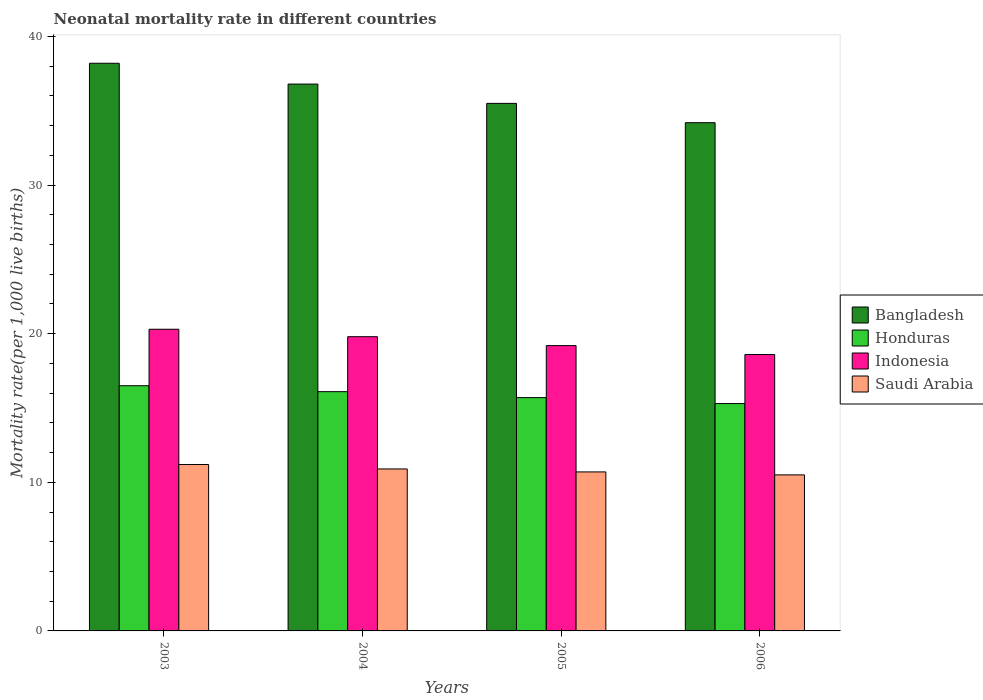Are the number of bars per tick equal to the number of legend labels?
Your response must be concise. Yes. How many bars are there on the 4th tick from the right?
Give a very brief answer. 4. What is the neonatal mortality rate in Indonesia in 2005?
Offer a terse response. 19.2. Across all years, what is the maximum neonatal mortality rate in Indonesia?
Make the answer very short. 20.3. Across all years, what is the minimum neonatal mortality rate in Bangladesh?
Your answer should be very brief. 34.2. In which year was the neonatal mortality rate in Indonesia minimum?
Provide a short and direct response. 2006. What is the total neonatal mortality rate in Bangladesh in the graph?
Offer a terse response. 144.7. What is the difference between the neonatal mortality rate in Saudi Arabia in 2003 and that in 2004?
Provide a short and direct response. 0.3. What is the difference between the neonatal mortality rate in Indonesia in 2003 and the neonatal mortality rate in Saudi Arabia in 2004?
Ensure brevity in your answer.  9.4. What is the average neonatal mortality rate in Indonesia per year?
Your response must be concise. 19.48. In the year 2005, what is the difference between the neonatal mortality rate in Saudi Arabia and neonatal mortality rate in Honduras?
Provide a short and direct response. -5. In how many years, is the neonatal mortality rate in Saudi Arabia greater than 8?
Provide a short and direct response. 4. What is the ratio of the neonatal mortality rate in Honduras in 2005 to that in 2006?
Offer a very short reply. 1.03. What is the difference between the highest and the second highest neonatal mortality rate in Honduras?
Your response must be concise. 0.4. Is it the case that in every year, the sum of the neonatal mortality rate in Saudi Arabia and neonatal mortality rate in Honduras is greater than the sum of neonatal mortality rate in Indonesia and neonatal mortality rate in Bangladesh?
Provide a short and direct response. No. Is it the case that in every year, the sum of the neonatal mortality rate in Indonesia and neonatal mortality rate in Honduras is greater than the neonatal mortality rate in Bangladesh?
Provide a succinct answer. No. Are the values on the major ticks of Y-axis written in scientific E-notation?
Provide a succinct answer. No. Does the graph contain any zero values?
Your answer should be very brief. No. What is the title of the graph?
Offer a very short reply. Neonatal mortality rate in different countries. Does "Kazakhstan" appear as one of the legend labels in the graph?
Make the answer very short. No. What is the label or title of the Y-axis?
Make the answer very short. Mortality rate(per 1,0 live births). What is the Mortality rate(per 1,000 live births) of Bangladesh in 2003?
Provide a succinct answer. 38.2. What is the Mortality rate(per 1,000 live births) of Honduras in 2003?
Offer a very short reply. 16.5. What is the Mortality rate(per 1,000 live births) in Indonesia in 2003?
Your response must be concise. 20.3. What is the Mortality rate(per 1,000 live births) of Bangladesh in 2004?
Ensure brevity in your answer.  36.8. What is the Mortality rate(per 1,000 live births) in Indonesia in 2004?
Your response must be concise. 19.8. What is the Mortality rate(per 1,000 live births) in Saudi Arabia in 2004?
Provide a short and direct response. 10.9. What is the Mortality rate(per 1,000 live births) of Bangladesh in 2005?
Ensure brevity in your answer.  35.5. What is the Mortality rate(per 1,000 live births) in Saudi Arabia in 2005?
Ensure brevity in your answer.  10.7. What is the Mortality rate(per 1,000 live births) in Bangladesh in 2006?
Your response must be concise. 34.2. What is the Mortality rate(per 1,000 live births) of Honduras in 2006?
Keep it short and to the point. 15.3. Across all years, what is the maximum Mortality rate(per 1,000 live births) in Bangladesh?
Give a very brief answer. 38.2. Across all years, what is the maximum Mortality rate(per 1,000 live births) in Honduras?
Offer a very short reply. 16.5. Across all years, what is the maximum Mortality rate(per 1,000 live births) in Indonesia?
Offer a terse response. 20.3. Across all years, what is the minimum Mortality rate(per 1,000 live births) of Bangladesh?
Your response must be concise. 34.2. Across all years, what is the minimum Mortality rate(per 1,000 live births) in Indonesia?
Your answer should be very brief. 18.6. Across all years, what is the minimum Mortality rate(per 1,000 live births) in Saudi Arabia?
Your response must be concise. 10.5. What is the total Mortality rate(per 1,000 live births) in Bangladesh in the graph?
Offer a terse response. 144.7. What is the total Mortality rate(per 1,000 live births) of Honduras in the graph?
Ensure brevity in your answer.  63.6. What is the total Mortality rate(per 1,000 live births) in Indonesia in the graph?
Make the answer very short. 77.9. What is the total Mortality rate(per 1,000 live births) of Saudi Arabia in the graph?
Provide a succinct answer. 43.3. What is the difference between the Mortality rate(per 1,000 live births) of Bangladesh in 2003 and that in 2004?
Your answer should be compact. 1.4. What is the difference between the Mortality rate(per 1,000 live births) of Saudi Arabia in 2003 and that in 2004?
Offer a terse response. 0.3. What is the difference between the Mortality rate(per 1,000 live births) in Indonesia in 2003 and that in 2005?
Offer a very short reply. 1.1. What is the difference between the Mortality rate(per 1,000 live births) in Saudi Arabia in 2003 and that in 2005?
Offer a very short reply. 0.5. What is the difference between the Mortality rate(per 1,000 live births) of Indonesia in 2003 and that in 2006?
Provide a succinct answer. 1.7. What is the difference between the Mortality rate(per 1,000 live births) in Saudi Arabia in 2004 and that in 2005?
Your answer should be compact. 0.2. What is the difference between the Mortality rate(per 1,000 live births) in Bangladesh in 2004 and that in 2006?
Provide a succinct answer. 2.6. What is the difference between the Mortality rate(per 1,000 live births) of Indonesia in 2004 and that in 2006?
Make the answer very short. 1.2. What is the difference between the Mortality rate(per 1,000 live births) of Bangladesh in 2005 and that in 2006?
Provide a succinct answer. 1.3. What is the difference between the Mortality rate(per 1,000 live births) in Honduras in 2005 and that in 2006?
Provide a short and direct response. 0.4. What is the difference between the Mortality rate(per 1,000 live births) in Bangladesh in 2003 and the Mortality rate(per 1,000 live births) in Honduras in 2004?
Your answer should be very brief. 22.1. What is the difference between the Mortality rate(per 1,000 live births) in Bangladesh in 2003 and the Mortality rate(per 1,000 live births) in Indonesia in 2004?
Your answer should be very brief. 18.4. What is the difference between the Mortality rate(per 1,000 live births) of Bangladesh in 2003 and the Mortality rate(per 1,000 live births) of Saudi Arabia in 2004?
Provide a short and direct response. 27.3. What is the difference between the Mortality rate(per 1,000 live births) of Bangladesh in 2003 and the Mortality rate(per 1,000 live births) of Honduras in 2005?
Offer a terse response. 22.5. What is the difference between the Mortality rate(per 1,000 live births) in Indonesia in 2003 and the Mortality rate(per 1,000 live births) in Saudi Arabia in 2005?
Provide a succinct answer. 9.6. What is the difference between the Mortality rate(per 1,000 live births) in Bangladesh in 2003 and the Mortality rate(per 1,000 live births) in Honduras in 2006?
Give a very brief answer. 22.9. What is the difference between the Mortality rate(per 1,000 live births) of Bangladesh in 2003 and the Mortality rate(per 1,000 live births) of Indonesia in 2006?
Your answer should be compact. 19.6. What is the difference between the Mortality rate(per 1,000 live births) of Bangladesh in 2003 and the Mortality rate(per 1,000 live births) of Saudi Arabia in 2006?
Offer a terse response. 27.7. What is the difference between the Mortality rate(per 1,000 live births) of Honduras in 2003 and the Mortality rate(per 1,000 live births) of Indonesia in 2006?
Your answer should be very brief. -2.1. What is the difference between the Mortality rate(per 1,000 live births) of Honduras in 2003 and the Mortality rate(per 1,000 live births) of Saudi Arabia in 2006?
Provide a succinct answer. 6. What is the difference between the Mortality rate(per 1,000 live births) in Indonesia in 2003 and the Mortality rate(per 1,000 live births) in Saudi Arabia in 2006?
Provide a short and direct response. 9.8. What is the difference between the Mortality rate(per 1,000 live births) in Bangladesh in 2004 and the Mortality rate(per 1,000 live births) in Honduras in 2005?
Offer a terse response. 21.1. What is the difference between the Mortality rate(per 1,000 live births) in Bangladesh in 2004 and the Mortality rate(per 1,000 live births) in Indonesia in 2005?
Ensure brevity in your answer.  17.6. What is the difference between the Mortality rate(per 1,000 live births) of Bangladesh in 2004 and the Mortality rate(per 1,000 live births) of Saudi Arabia in 2005?
Your answer should be compact. 26.1. What is the difference between the Mortality rate(per 1,000 live births) of Honduras in 2004 and the Mortality rate(per 1,000 live births) of Saudi Arabia in 2005?
Give a very brief answer. 5.4. What is the difference between the Mortality rate(per 1,000 live births) in Bangladesh in 2004 and the Mortality rate(per 1,000 live births) in Honduras in 2006?
Offer a very short reply. 21.5. What is the difference between the Mortality rate(per 1,000 live births) in Bangladesh in 2004 and the Mortality rate(per 1,000 live births) in Indonesia in 2006?
Provide a succinct answer. 18.2. What is the difference between the Mortality rate(per 1,000 live births) of Bangladesh in 2004 and the Mortality rate(per 1,000 live births) of Saudi Arabia in 2006?
Your answer should be compact. 26.3. What is the difference between the Mortality rate(per 1,000 live births) in Indonesia in 2004 and the Mortality rate(per 1,000 live births) in Saudi Arabia in 2006?
Your answer should be compact. 9.3. What is the difference between the Mortality rate(per 1,000 live births) of Bangladesh in 2005 and the Mortality rate(per 1,000 live births) of Honduras in 2006?
Your answer should be very brief. 20.2. What is the difference between the Mortality rate(per 1,000 live births) in Honduras in 2005 and the Mortality rate(per 1,000 live births) in Saudi Arabia in 2006?
Offer a very short reply. 5.2. What is the difference between the Mortality rate(per 1,000 live births) in Indonesia in 2005 and the Mortality rate(per 1,000 live births) in Saudi Arabia in 2006?
Make the answer very short. 8.7. What is the average Mortality rate(per 1,000 live births) in Bangladesh per year?
Keep it short and to the point. 36.17. What is the average Mortality rate(per 1,000 live births) in Honduras per year?
Make the answer very short. 15.9. What is the average Mortality rate(per 1,000 live births) in Indonesia per year?
Keep it short and to the point. 19.48. What is the average Mortality rate(per 1,000 live births) of Saudi Arabia per year?
Make the answer very short. 10.82. In the year 2003, what is the difference between the Mortality rate(per 1,000 live births) in Bangladesh and Mortality rate(per 1,000 live births) in Honduras?
Offer a terse response. 21.7. In the year 2003, what is the difference between the Mortality rate(per 1,000 live births) of Bangladesh and Mortality rate(per 1,000 live births) of Indonesia?
Ensure brevity in your answer.  17.9. In the year 2003, what is the difference between the Mortality rate(per 1,000 live births) in Honduras and Mortality rate(per 1,000 live births) in Saudi Arabia?
Ensure brevity in your answer.  5.3. In the year 2003, what is the difference between the Mortality rate(per 1,000 live births) in Indonesia and Mortality rate(per 1,000 live births) in Saudi Arabia?
Provide a succinct answer. 9.1. In the year 2004, what is the difference between the Mortality rate(per 1,000 live births) of Bangladesh and Mortality rate(per 1,000 live births) of Honduras?
Provide a short and direct response. 20.7. In the year 2004, what is the difference between the Mortality rate(per 1,000 live births) of Bangladesh and Mortality rate(per 1,000 live births) of Saudi Arabia?
Your response must be concise. 25.9. In the year 2004, what is the difference between the Mortality rate(per 1,000 live births) of Honduras and Mortality rate(per 1,000 live births) of Saudi Arabia?
Give a very brief answer. 5.2. In the year 2005, what is the difference between the Mortality rate(per 1,000 live births) of Bangladesh and Mortality rate(per 1,000 live births) of Honduras?
Your answer should be compact. 19.8. In the year 2005, what is the difference between the Mortality rate(per 1,000 live births) of Bangladesh and Mortality rate(per 1,000 live births) of Saudi Arabia?
Ensure brevity in your answer.  24.8. In the year 2005, what is the difference between the Mortality rate(per 1,000 live births) of Honduras and Mortality rate(per 1,000 live births) of Indonesia?
Provide a short and direct response. -3.5. In the year 2005, what is the difference between the Mortality rate(per 1,000 live births) in Honduras and Mortality rate(per 1,000 live births) in Saudi Arabia?
Keep it short and to the point. 5. In the year 2006, what is the difference between the Mortality rate(per 1,000 live births) of Bangladesh and Mortality rate(per 1,000 live births) of Saudi Arabia?
Ensure brevity in your answer.  23.7. In the year 2006, what is the difference between the Mortality rate(per 1,000 live births) in Honduras and Mortality rate(per 1,000 live births) in Saudi Arabia?
Provide a succinct answer. 4.8. In the year 2006, what is the difference between the Mortality rate(per 1,000 live births) in Indonesia and Mortality rate(per 1,000 live births) in Saudi Arabia?
Keep it short and to the point. 8.1. What is the ratio of the Mortality rate(per 1,000 live births) in Bangladesh in 2003 to that in 2004?
Make the answer very short. 1.04. What is the ratio of the Mortality rate(per 1,000 live births) in Honduras in 2003 to that in 2004?
Keep it short and to the point. 1.02. What is the ratio of the Mortality rate(per 1,000 live births) of Indonesia in 2003 to that in 2004?
Provide a short and direct response. 1.03. What is the ratio of the Mortality rate(per 1,000 live births) of Saudi Arabia in 2003 to that in 2004?
Your answer should be very brief. 1.03. What is the ratio of the Mortality rate(per 1,000 live births) of Bangladesh in 2003 to that in 2005?
Provide a short and direct response. 1.08. What is the ratio of the Mortality rate(per 1,000 live births) in Honduras in 2003 to that in 2005?
Your answer should be compact. 1.05. What is the ratio of the Mortality rate(per 1,000 live births) of Indonesia in 2003 to that in 2005?
Your answer should be very brief. 1.06. What is the ratio of the Mortality rate(per 1,000 live births) in Saudi Arabia in 2003 to that in 2005?
Offer a terse response. 1.05. What is the ratio of the Mortality rate(per 1,000 live births) in Bangladesh in 2003 to that in 2006?
Give a very brief answer. 1.12. What is the ratio of the Mortality rate(per 1,000 live births) in Honduras in 2003 to that in 2006?
Your answer should be very brief. 1.08. What is the ratio of the Mortality rate(per 1,000 live births) in Indonesia in 2003 to that in 2006?
Make the answer very short. 1.09. What is the ratio of the Mortality rate(per 1,000 live births) of Saudi Arabia in 2003 to that in 2006?
Provide a short and direct response. 1.07. What is the ratio of the Mortality rate(per 1,000 live births) in Bangladesh in 2004 to that in 2005?
Your response must be concise. 1.04. What is the ratio of the Mortality rate(per 1,000 live births) of Honduras in 2004 to that in 2005?
Offer a terse response. 1.03. What is the ratio of the Mortality rate(per 1,000 live births) in Indonesia in 2004 to that in 2005?
Make the answer very short. 1.03. What is the ratio of the Mortality rate(per 1,000 live births) of Saudi Arabia in 2004 to that in 2005?
Make the answer very short. 1.02. What is the ratio of the Mortality rate(per 1,000 live births) in Bangladesh in 2004 to that in 2006?
Your answer should be compact. 1.08. What is the ratio of the Mortality rate(per 1,000 live births) of Honduras in 2004 to that in 2006?
Give a very brief answer. 1.05. What is the ratio of the Mortality rate(per 1,000 live births) of Indonesia in 2004 to that in 2006?
Give a very brief answer. 1.06. What is the ratio of the Mortality rate(per 1,000 live births) in Saudi Arabia in 2004 to that in 2006?
Provide a succinct answer. 1.04. What is the ratio of the Mortality rate(per 1,000 live births) of Bangladesh in 2005 to that in 2006?
Offer a terse response. 1.04. What is the ratio of the Mortality rate(per 1,000 live births) of Honduras in 2005 to that in 2006?
Offer a very short reply. 1.03. What is the ratio of the Mortality rate(per 1,000 live births) in Indonesia in 2005 to that in 2006?
Your answer should be compact. 1.03. What is the ratio of the Mortality rate(per 1,000 live births) of Saudi Arabia in 2005 to that in 2006?
Give a very brief answer. 1.02. What is the difference between the highest and the second highest Mortality rate(per 1,000 live births) of Indonesia?
Keep it short and to the point. 0.5. What is the difference between the highest and the lowest Mortality rate(per 1,000 live births) of Honduras?
Keep it short and to the point. 1.2. 